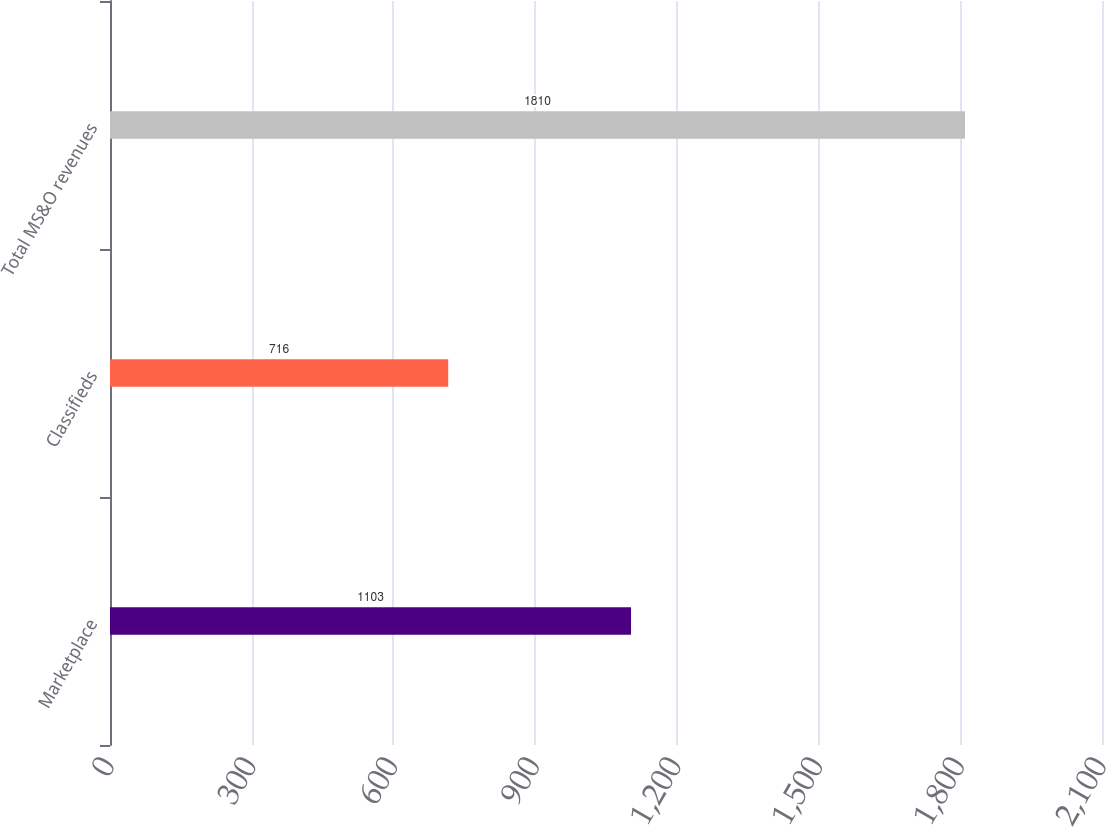<chart> <loc_0><loc_0><loc_500><loc_500><bar_chart><fcel>Marketplace<fcel>Classifieds<fcel>Total MS&O revenues<nl><fcel>1103<fcel>716<fcel>1810<nl></chart> 